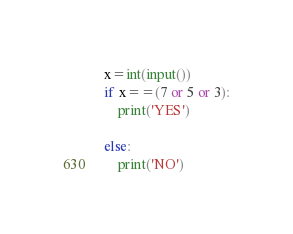Convert code to text. <code><loc_0><loc_0><loc_500><loc_500><_Python_>x=int(input())
if x==(7 or 5 or 3):
    print('YES')

else:
    print('NO')
</code> 